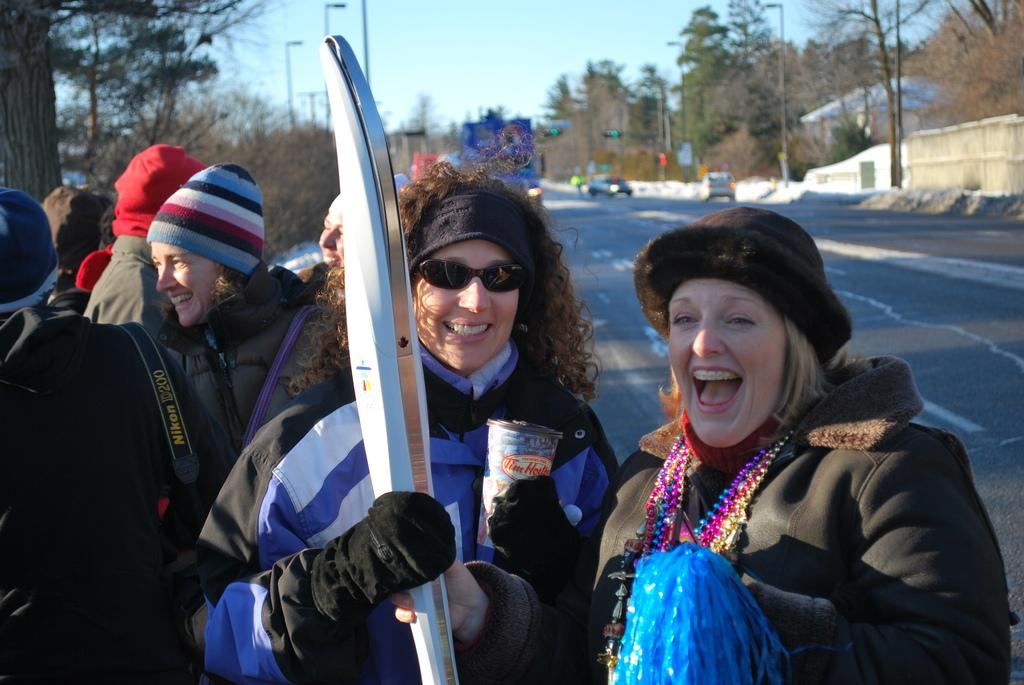What are the people in the image wearing? The people in the image are wearing jackets. What are the people holding and what expression do they have? Two people are holding objects and smiling. Can you describe the background of the image? The background is blurred, but trees, light poles, and vehicles on the road are visible. What type of waste can be seen on the ground in the image? There is no waste visible on the ground in the image. How many fingers can be seen pointing at the spot in the image? There is no spot or fingers pointing at it in the image. 